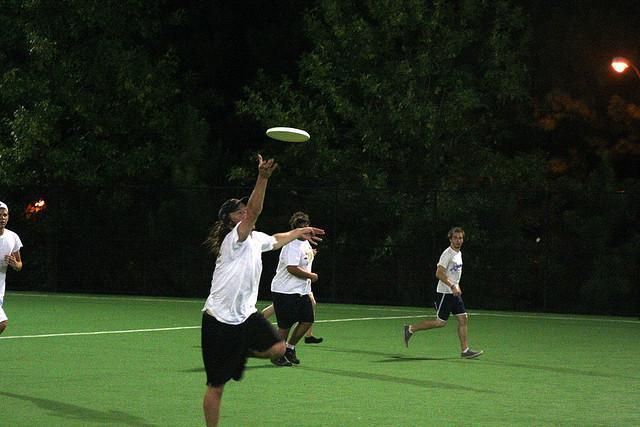How many people on the field?
Give a very brief answer. 5. How many people are visible?
Give a very brief answer. 3. 